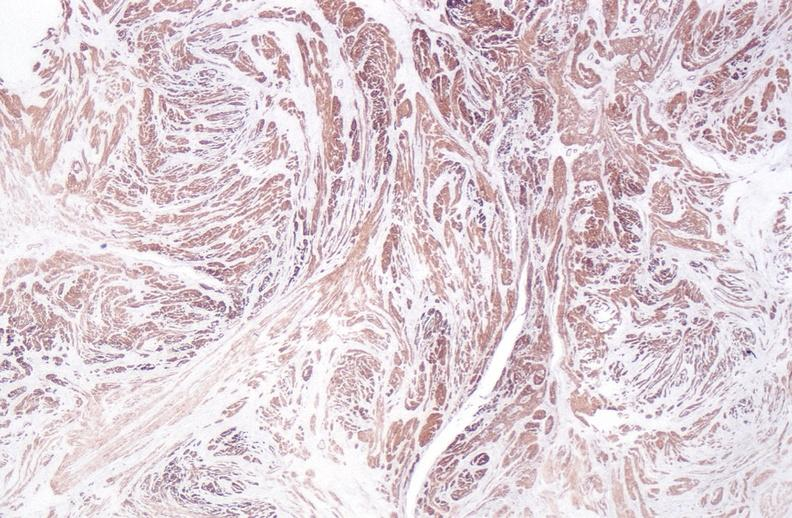what stain?
Answer the question using a single word or phrase. Alpha smooth muscle actin immunohistochemical 